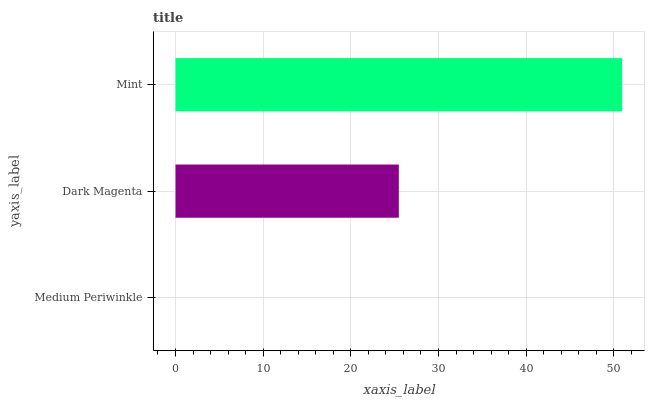Is Medium Periwinkle the minimum?
Answer yes or no. Yes. Is Mint the maximum?
Answer yes or no. Yes. Is Dark Magenta the minimum?
Answer yes or no. No. Is Dark Magenta the maximum?
Answer yes or no. No. Is Dark Magenta greater than Medium Periwinkle?
Answer yes or no. Yes. Is Medium Periwinkle less than Dark Magenta?
Answer yes or no. Yes. Is Medium Periwinkle greater than Dark Magenta?
Answer yes or no. No. Is Dark Magenta less than Medium Periwinkle?
Answer yes or no. No. Is Dark Magenta the high median?
Answer yes or no. Yes. Is Dark Magenta the low median?
Answer yes or no. Yes. Is Medium Periwinkle the high median?
Answer yes or no. No. Is Mint the low median?
Answer yes or no. No. 